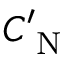<formula> <loc_0><loc_0><loc_500><loc_500>C _ { N } ^ { \prime }</formula> 